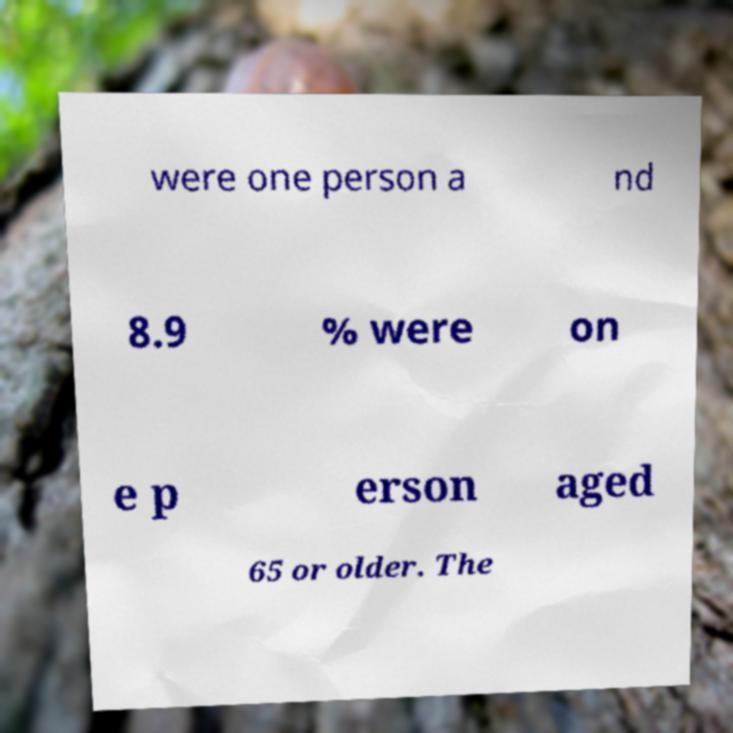Can you read and provide the text displayed in the image?This photo seems to have some interesting text. Can you extract and type it out for me? were one person a nd 8.9 % were on e p erson aged 65 or older. The 